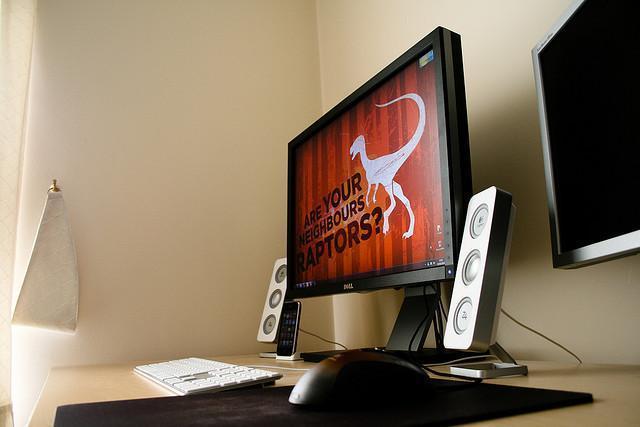How many keyboards can be seen?
Give a very brief answer. 1. How many tvs are visible?
Give a very brief answer. 2. How many sheep are there?
Give a very brief answer. 0. 